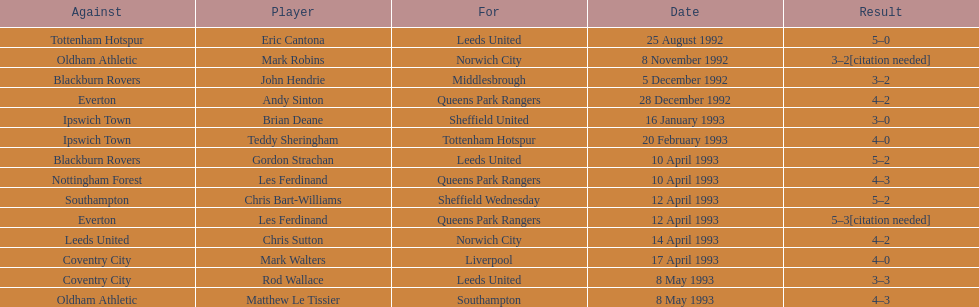Name the only player from france. Eric Cantona. 